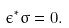<formula> <loc_0><loc_0><loc_500><loc_500>\epsilon ^ { \ast } \sigma = 0 .</formula> 